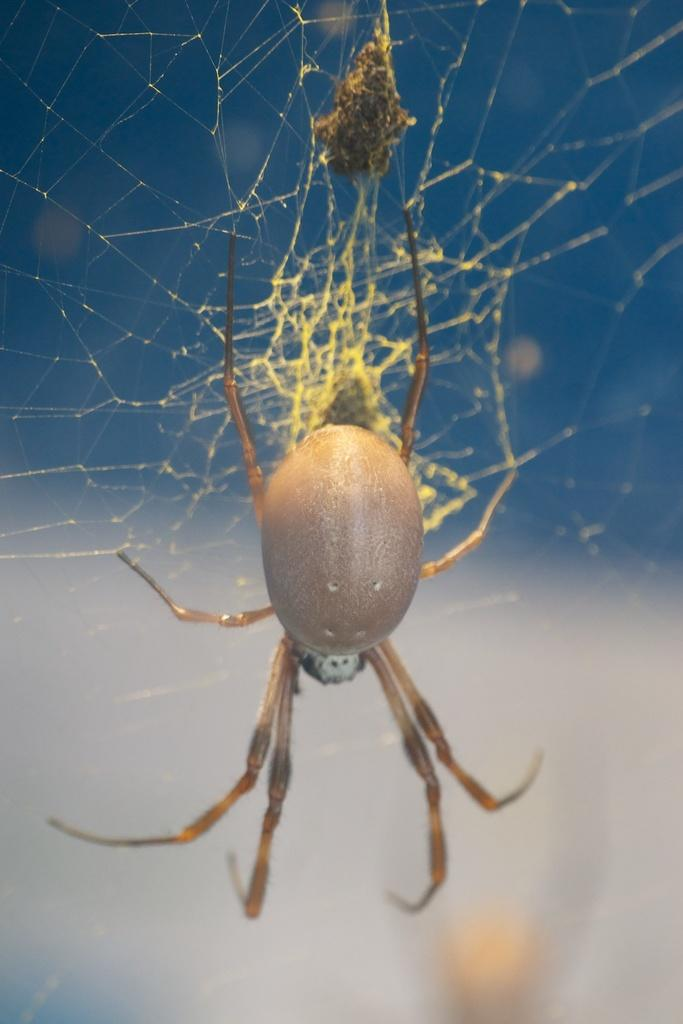What is present in the image? There is a spider in the image. Where is the spider located? The spider is in a spider's web. What type of music is the spider playing in the image? There is no indication in the image that the spider is playing any music. Is there a carriage visible in the image? No, there is no carriage present in the image. 